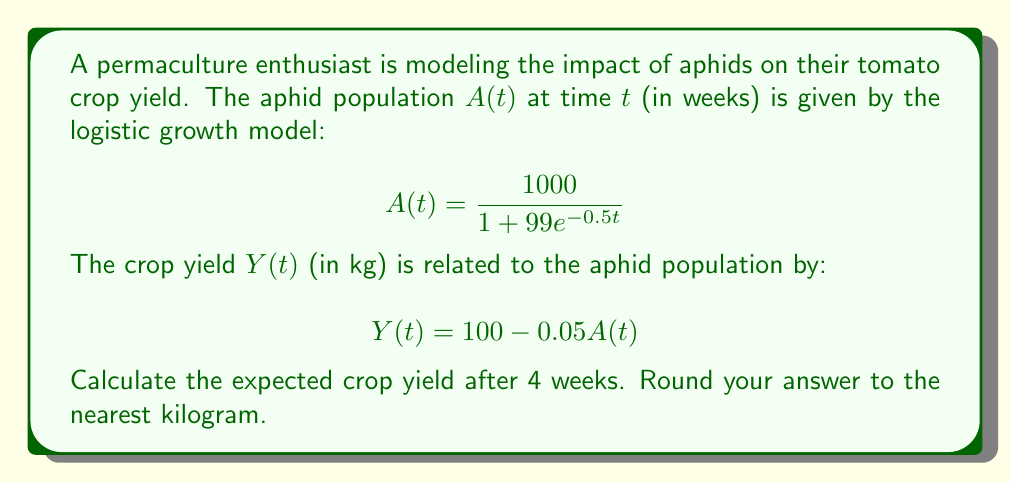Could you help me with this problem? To solve this problem, we'll follow these steps:

1. Calculate the aphid population at $t = 4$ weeks:
   $$A(4) = \frac{1000}{1 + 99e^{-0.5(4)}}$$
   $$= \frac{1000}{1 + 99e^{-2}}$$
   $$= \frac{1000}{1 + 99(0.1353)}$$
   $$= \frac{1000}{14.3947}$$
   $$= 69.47$$

2. Use the aphid population to calculate the crop yield:
   $$Y(4) = 100 - 0.05A(4)$$
   $$= 100 - 0.05(69.47)$$
   $$= 100 - 3.4735$$
   $$= 96.5265$$

3. Round the result to the nearest kilogram:
   96.5265 ≈ 97 kg
Answer: 97 kg 